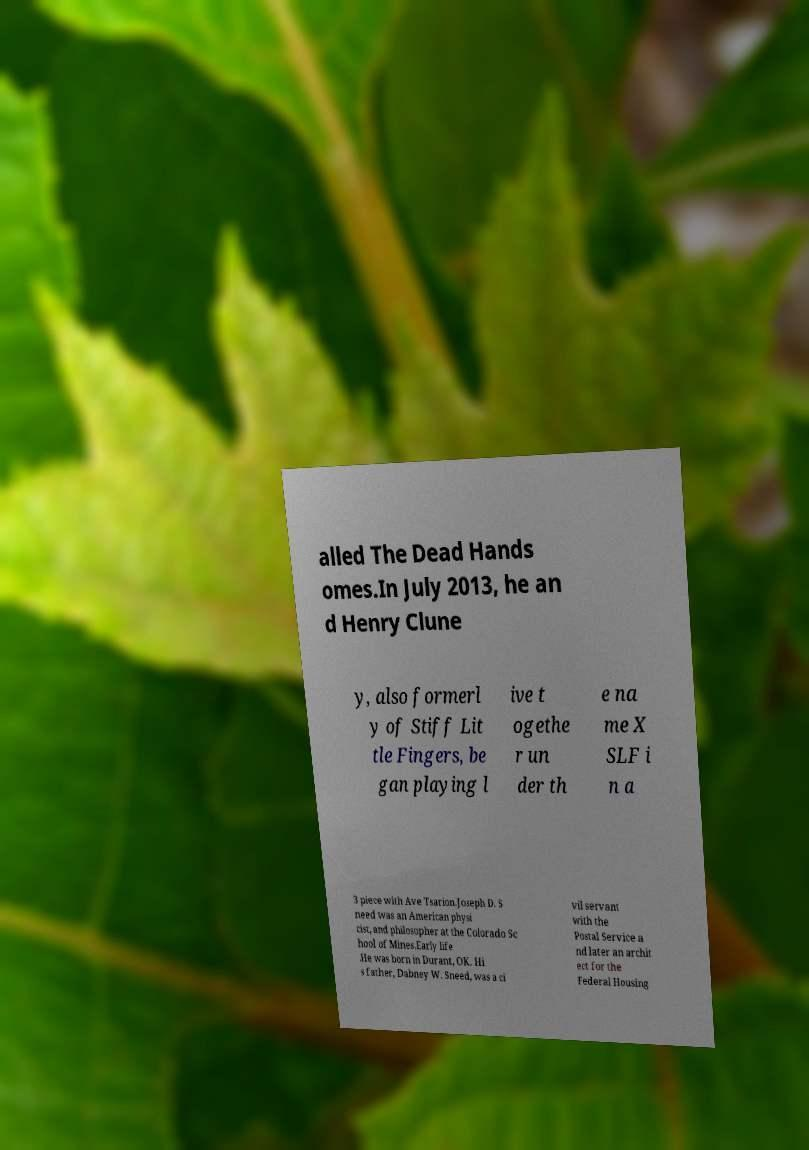Please read and relay the text visible in this image. What does it say? alled The Dead Hands omes.In July 2013, he an d Henry Clune y, also formerl y of Stiff Lit tle Fingers, be gan playing l ive t ogethe r un der th e na me X SLF i n a 3 piece with Ave Tsarion.Joseph D. S need was an American physi cist, and philosopher at the Colorado Sc hool of Mines.Early life .He was born in Durant, OK. Hi s father, Dabney W. Sneed, was a ci vil servant with the Postal Service a nd later an archit ect for the Federal Housing 